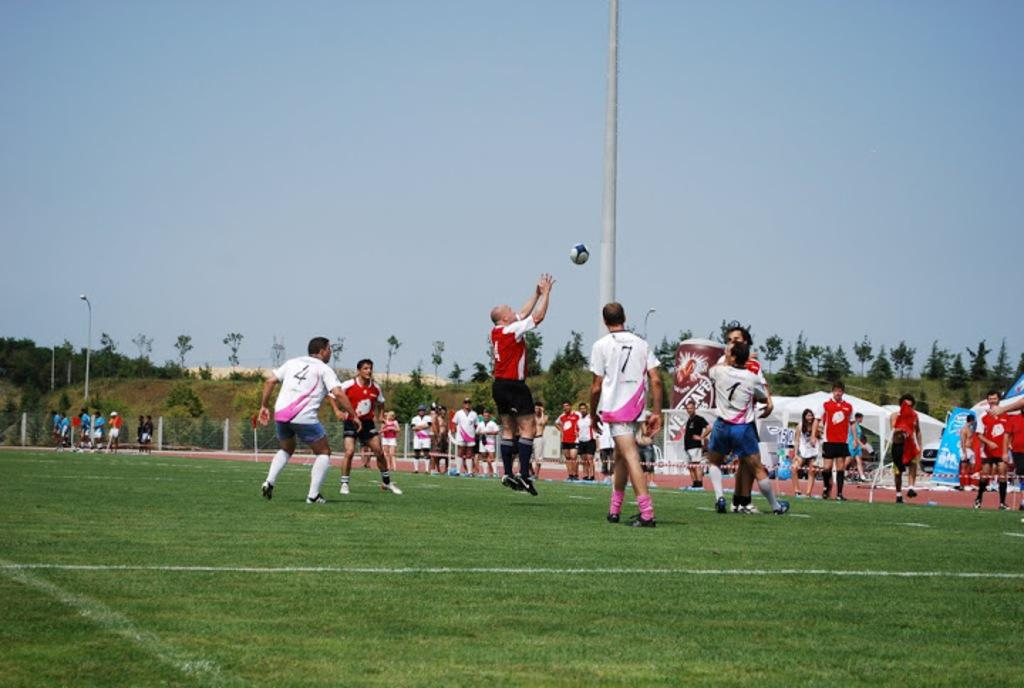<image>
Render a clear and concise summary of the photo. Several soccer players, including jersey numbers 4 and 7, compete on the field. 